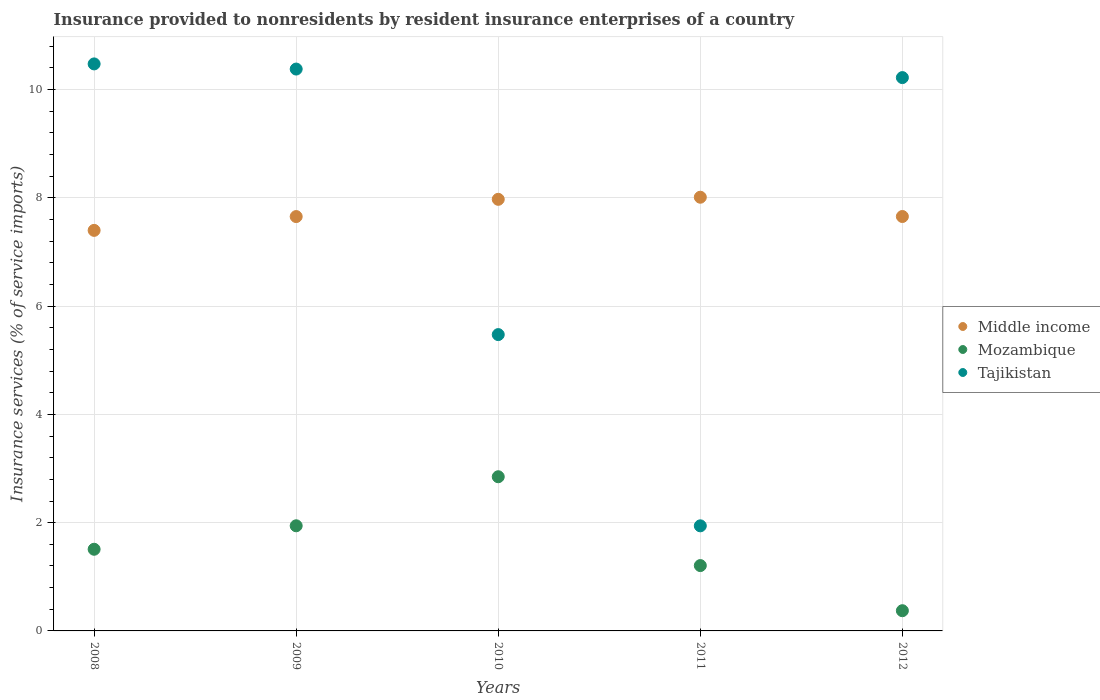How many different coloured dotlines are there?
Offer a terse response. 3. Is the number of dotlines equal to the number of legend labels?
Keep it short and to the point. Yes. What is the insurance provided to nonresidents in Tajikistan in 2012?
Your response must be concise. 10.22. Across all years, what is the maximum insurance provided to nonresidents in Tajikistan?
Offer a very short reply. 10.47. Across all years, what is the minimum insurance provided to nonresidents in Tajikistan?
Your response must be concise. 1.94. What is the total insurance provided to nonresidents in Middle income in the graph?
Make the answer very short. 38.69. What is the difference between the insurance provided to nonresidents in Middle income in 2008 and that in 2009?
Ensure brevity in your answer.  -0.26. What is the difference between the insurance provided to nonresidents in Middle income in 2008 and the insurance provided to nonresidents in Mozambique in 2012?
Keep it short and to the point. 7.03. What is the average insurance provided to nonresidents in Middle income per year?
Your response must be concise. 7.74. In the year 2009, what is the difference between the insurance provided to nonresidents in Tajikistan and insurance provided to nonresidents in Middle income?
Your answer should be very brief. 2.72. In how many years, is the insurance provided to nonresidents in Mozambique greater than 2.8 %?
Offer a very short reply. 1. What is the ratio of the insurance provided to nonresidents in Middle income in 2008 to that in 2012?
Offer a terse response. 0.97. What is the difference between the highest and the second highest insurance provided to nonresidents in Middle income?
Provide a short and direct response. 0.04. What is the difference between the highest and the lowest insurance provided to nonresidents in Middle income?
Offer a very short reply. 0.61. Is the sum of the insurance provided to nonresidents in Mozambique in 2008 and 2011 greater than the maximum insurance provided to nonresidents in Tajikistan across all years?
Provide a succinct answer. No. Is it the case that in every year, the sum of the insurance provided to nonresidents in Mozambique and insurance provided to nonresidents in Tajikistan  is greater than the insurance provided to nonresidents in Middle income?
Ensure brevity in your answer.  No. How many dotlines are there?
Your answer should be compact. 3. How many years are there in the graph?
Provide a succinct answer. 5. What is the difference between two consecutive major ticks on the Y-axis?
Offer a very short reply. 2. How are the legend labels stacked?
Make the answer very short. Vertical. What is the title of the graph?
Keep it short and to the point. Insurance provided to nonresidents by resident insurance enterprises of a country. Does "South Asia" appear as one of the legend labels in the graph?
Provide a succinct answer. No. What is the label or title of the Y-axis?
Offer a very short reply. Insurance services (% of service imports). What is the Insurance services (% of service imports) in Middle income in 2008?
Give a very brief answer. 7.4. What is the Insurance services (% of service imports) in Mozambique in 2008?
Provide a short and direct response. 1.51. What is the Insurance services (% of service imports) of Tajikistan in 2008?
Give a very brief answer. 10.47. What is the Insurance services (% of service imports) of Middle income in 2009?
Your answer should be compact. 7.65. What is the Insurance services (% of service imports) of Mozambique in 2009?
Your answer should be compact. 1.94. What is the Insurance services (% of service imports) of Tajikistan in 2009?
Your response must be concise. 10.38. What is the Insurance services (% of service imports) in Middle income in 2010?
Ensure brevity in your answer.  7.97. What is the Insurance services (% of service imports) in Mozambique in 2010?
Make the answer very short. 2.85. What is the Insurance services (% of service imports) in Tajikistan in 2010?
Offer a terse response. 5.47. What is the Insurance services (% of service imports) in Middle income in 2011?
Ensure brevity in your answer.  8.01. What is the Insurance services (% of service imports) in Mozambique in 2011?
Keep it short and to the point. 1.21. What is the Insurance services (% of service imports) of Tajikistan in 2011?
Ensure brevity in your answer.  1.94. What is the Insurance services (% of service imports) of Middle income in 2012?
Ensure brevity in your answer.  7.66. What is the Insurance services (% of service imports) of Mozambique in 2012?
Give a very brief answer. 0.37. What is the Insurance services (% of service imports) in Tajikistan in 2012?
Your answer should be compact. 10.22. Across all years, what is the maximum Insurance services (% of service imports) of Middle income?
Offer a terse response. 8.01. Across all years, what is the maximum Insurance services (% of service imports) of Mozambique?
Your answer should be very brief. 2.85. Across all years, what is the maximum Insurance services (% of service imports) in Tajikistan?
Provide a short and direct response. 10.47. Across all years, what is the minimum Insurance services (% of service imports) in Middle income?
Offer a very short reply. 7.4. Across all years, what is the minimum Insurance services (% of service imports) in Mozambique?
Your answer should be compact. 0.37. Across all years, what is the minimum Insurance services (% of service imports) in Tajikistan?
Your answer should be very brief. 1.94. What is the total Insurance services (% of service imports) of Middle income in the graph?
Provide a succinct answer. 38.69. What is the total Insurance services (% of service imports) of Mozambique in the graph?
Make the answer very short. 7.88. What is the total Insurance services (% of service imports) of Tajikistan in the graph?
Your answer should be very brief. 38.49. What is the difference between the Insurance services (% of service imports) in Middle income in 2008 and that in 2009?
Provide a succinct answer. -0.26. What is the difference between the Insurance services (% of service imports) of Mozambique in 2008 and that in 2009?
Provide a short and direct response. -0.43. What is the difference between the Insurance services (% of service imports) in Tajikistan in 2008 and that in 2009?
Make the answer very short. 0.1. What is the difference between the Insurance services (% of service imports) in Middle income in 2008 and that in 2010?
Make the answer very short. -0.57. What is the difference between the Insurance services (% of service imports) in Mozambique in 2008 and that in 2010?
Give a very brief answer. -1.34. What is the difference between the Insurance services (% of service imports) in Tajikistan in 2008 and that in 2010?
Provide a short and direct response. 5. What is the difference between the Insurance services (% of service imports) in Middle income in 2008 and that in 2011?
Ensure brevity in your answer.  -0.61. What is the difference between the Insurance services (% of service imports) of Mozambique in 2008 and that in 2011?
Make the answer very short. 0.3. What is the difference between the Insurance services (% of service imports) in Tajikistan in 2008 and that in 2011?
Keep it short and to the point. 8.53. What is the difference between the Insurance services (% of service imports) in Middle income in 2008 and that in 2012?
Your response must be concise. -0.26. What is the difference between the Insurance services (% of service imports) in Mozambique in 2008 and that in 2012?
Your response must be concise. 1.14. What is the difference between the Insurance services (% of service imports) of Tajikistan in 2008 and that in 2012?
Offer a very short reply. 0.25. What is the difference between the Insurance services (% of service imports) in Middle income in 2009 and that in 2010?
Ensure brevity in your answer.  -0.32. What is the difference between the Insurance services (% of service imports) in Mozambique in 2009 and that in 2010?
Offer a very short reply. -0.91. What is the difference between the Insurance services (% of service imports) in Tajikistan in 2009 and that in 2010?
Ensure brevity in your answer.  4.91. What is the difference between the Insurance services (% of service imports) in Middle income in 2009 and that in 2011?
Make the answer very short. -0.36. What is the difference between the Insurance services (% of service imports) of Mozambique in 2009 and that in 2011?
Provide a succinct answer. 0.74. What is the difference between the Insurance services (% of service imports) in Tajikistan in 2009 and that in 2011?
Your answer should be very brief. 8.44. What is the difference between the Insurance services (% of service imports) in Middle income in 2009 and that in 2012?
Give a very brief answer. -0. What is the difference between the Insurance services (% of service imports) of Mozambique in 2009 and that in 2012?
Offer a very short reply. 1.57. What is the difference between the Insurance services (% of service imports) in Tajikistan in 2009 and that in 2012?
Ensure brevity in your answer.  0.16. What is the difference between the Insurance services (% of service imports) in Middle income in 2010 and that in 2011?
Your answer should be compact. -0.04. What is the difference between the Insurance services (% of service imports) of Mozambique in 2010 and that in 2011?
Your answer should be very brief. 1.64. What is the difference between the Insurance services (% of service imports) in Tajikistan in 2010 and that in 2011?
Provide a short and direct response. 3.53. What is the difference between the Insurance services (% of service imports) of Middle income in 2010 and that in 2012?
Your answer should be compact. 0.32. What is the difference between the Insurance services (% of service imports) of Mozambique in 2010 and that in 2012?
Provide a short and direct response. 2.47. What is the difference between the Insurance services (% of service imports) of Tajikistan in 2010 and that in 2012?
Offer a terse response. -4.75. What is the difference between the Insurance services (% of service imports) in Middle income in 2011 and that in 2012?
Ensure brevity in your answer.  0.36. What is the difference between the Insurance services (% of service imports) in Mozambique in 2011 and that in 2012?
Provide a short and direct response. 0.83. What is the difference between the Insurance services (% of service imports) of Tajikistan in 2011 and that in 2012?
Ensure brevity in your answer.  -8.28. What is the difference between the Insurance services (% of service imports) of Middle income in 2008 and the Insurance services (% of service imports) of Mozambique in 2009?
Keep it short and to the point. 5.46. What is the difference between the Insurance services (% of service imports) in Middle income in 2008 and the Insurance services (% of service imports) in Tajikistan in 2009?
Make the answer very short. -2.98. What is the difference between the Insurance services (% of service imports) in Mozambique in 2008 and the Insurance services (% of service imports) in Tajikistan in 2009?
Make the answer very short. -8.87. What is the difference between the Insurance services (% of service imports) of Middle income in 2008 and the Insurance services (% of service imports) of Mozambique in 2010?
Provide a short and direct response. 4.55. What is the difference between the Insurance services (% of service imports) in Middle income in 2008 and the Insurance services (% of service imports) in Tajikistan in 2010?
Keep it short and to the point. 1.93. What is the difference between the Insurance services (% of service imports) in Mozambique in 2008 and the Insurance services (% of service imports) in Tajikistan in 2010?
Your answer should be compact. -3.97. What is the difference between the Insurance services (% of service imports) in Middle income in 2008 and the Insurance services (% of service imports) in Mozambique in 2011?
Your response must be concise. 6.19. What is the difference between the Insurance services (% of service imports) in Middle income in 2008 and the Insurance services (% of service imports) in Tajikistan in 2011?
Your answer should be very brief. 5.46. What is the difference between the Insurance services (% of service imports) of Mozambique in 2008 and the Insurance services (% of service imports) of Tajikistan in 2011?
Your answer should be very brief. -0.43. What is the difference between the Insurance services (% of service imports) of Middle income in 2008 and the Insurance services (% of service imports) of Mozambique in 2012?
Offer a very short reply. 7.03. What is the difference between the Insurance services (% of service imports) of Middle income in 2008 and the Insurance services (% of service imports) of Tajikistan in 2012?
Give a very brief answer. -2.82. What is the difference between the Insurance services (% of service imports) in Mozambique in 2008 and the Insurance services (% of service imports) in Tajikistan in 2012?
Offer a terse response. -8.71. What is the difference between the Insurance services (% of service imports) of Middle income in 2009 and the Insurance services (% of service imports) of Mozambique in 2010?
Provide a succinct answer. 4.81. What is the difference between the Insurance services (% of service imports) in Middle income in 2009 and the Insurance services (% of service imports) in Tajikistan in 2010?
Your answer should be very brief. 2.18. What is the difference between the Insurance services (% of service imports) in Mozambique in 2009 and the Insurance services (% of service imports) in Tajikistan in 2010?
Your answer should be very brief. -3.53. What is the difference between the Insurance services (% of service imports) in Middle income in 2009 and the Insurance services (% of service imports) in Mozambique in 2011?
Provide a short and direct response. 6.45. What is the difference between the Insurance services (% of service imports) in Middle income in 2009 and the Insurance services (% of service imports) in Tajikistan in 2011?
Offer a very short reply. 5.71. What is the difference between the Insurance services (% of service imports) of Mozambique in 2009 and the Insurance services (% of service imports) of Tajikistan in 2011?
Provide a short and direct response. 0. What is the difference between the Insurance services (% of service imports) in Middle income in 2009 and the Insurance services (% of service imports) in Mozambique in 2012?
Your answer should be compact. 7.28. What is the difference between the Insurance services (% of service imports) of Middle income in 2009 and the Insurance services (% of service imports) of Tajikistan in 2012?
Offer a terse response. -2.57. What is the difference between the Insurance services (% of service imports) in Mozambique in 2009 and the Insurance services (% of service imports) in Tajikistan in 2012?
Make the answer very short. -8.28. What is the difference between the Insurance services (% of service imports) in Middle income in 2010 and the Insurance services (% of service imports) in Mozambique in 2011?
Keep it short and to the point. 6.77. What is the difference between the Insurance services (% of service imports) in Middle income in 2010 and the Insurance services (% of service imports) in Tajikistan in 2011?
Give a very brief answer. 6.03. What is the difference between the Insurance services (% of service imports) in Mozambique in 2010 and the Insurance services (% of service imports) in Tajikistan in 2011?
Your response must be concise. 0.91. What is the difference between the Insurance services (% of service imports) of Middle income in 2010 and the Insurance services (% of service imports) of Mozambique in 2012?
Make the answer very short. 7.6. What is the difference between the Insurance services (% of service imports) of Middle income in 2010 and the Insurance services (% of service imports) of Tajikistan in 2012?
Keep it short and to the point. -2.25. What is the difference between the Insurance services (% of service imports) in Mozambique in 2010 and the Insurance services (% of service imports) in Tajikistan in 2012?
Offer a terse response. -7.37. What is the difference between the Insurance services (% of service imports) of Middle income in 2011 and the Insurance services (% of service imports) of Mozambique in 2012?
Offer a very short reply. 7.64. What is the difference between the Insurance services (% of service imports) in Middle income in 2011 and the Insurance services (% of service imports) in Tajikistan in 2012?
Offer a terse response. -2.21. What is the difference between the Insurance services (% of service imports) in Mozambique in 2011 and the Insurance services (% of service imports) in Tajikistan in 2012?
Your answer should be very brief. -9.01. What is the average Insurance services (% of service imports) in Middle income per year?
Give a very brief answer. 7.74. What is the average Insurance services (% of service imports) in Mozambique per year?
Your answer should be very brief. 1.58. What is the average Insurance services (% of service imports) of Tajikistan per year?
Keep it short and to the point. 7.7. In the year 2008, what is the difference between the Insurance services (% of service imports) of Middle income and Insurance services (% of service imports) of Mozambique?
Make the answer very short. 5.89. In the year 2008, what is the difference between the Insurance services (% of service imports) of Middle income and Insurance services (% of service imports) of Tajikistan?
Make the answer very short. -3.08. In the year 2008, what is the difference between the Insurance services (% of service imports) of Mozambique and Insurance services (% of service imports) of Tajikistan?
Your response must be concise. -8.97. In the year 2009, what is the difference between the Insurance services (% of service imports) in Middle income and Insurance services (% of service imports) in Mozambique?
Offer a very short reply. 5.71. In the year 2009, what is the difference between the Insurance services (% of service imports) of Middle income and Insurance services (% of service imports) of Tajikistan?
Give a very brief answer. -2.72. In the year 2009, what is the difference between the Insurance services (% of service imports) in Mozambique and Insurance services (% of service imports) in Tajikistan?
Your answer should be compact. -8.44. In the year 2010, what is the difference between the Insurance services (% of service imports) of Middle income and Insurance services (% of service imports) of Mozambique?
Ensure brevity in your answer.  5.12. In the year 2010, what is the difference between the Insurance services (% of service imports) of Middle income and Insurance services (% of service imports) of Tajikistan?
Make the answer very short. 2.5. In the year 2010, what is the difference between the Insurance services (% of service imports) of Mozambique and Insurance services (% of service imports) of Tajikistan?
Provide a short and direct response. -2.63. In the year 2011, what is the difference between the Insurance services (% of service imports) in Middle income and Insurance services (% of service imports) in Mozambique?
Ensure brevity in your answer.  6.8. In the year 2011, what is the difference between the Insurance services (% of service imports) in Middle income and Insurance services (% of service imports) in Tajikistan?
Ensure brevity in your answer.  6.07. In the year 2011, what is the difference between the Insurance services (% of service imports) in Mozambique and Insurance services (% of service imports) in Tajikistan?
Give a very brief answer. -0.73. In the year 2012, what is the difference between the Insurance services (% of service imports) in Middle income and Insurance services (% of service imports) in Mozambique?
Ensure brevity in your answer.  7.28. In the year 2012, what is the difference between the Insurance services (% of service imports) in Middle income and Insurance services (% of service imports) in Tajikistan?
Make the answer very short. -2.57. In the year 2012, what is the difference between the Insurance services (% of service imports) in Mozambique and Insurance services (% of service imports) in Tajikistan?
Offer a terse response. -9.85. What is the ratio of the Insurance services (% of service imports) of Middle income in 2008 to that in 2009?
Give a very brief answer. 0.97. What is the ratio of the Insurance services (% of service imports) in Mozambique in 2008 to that in 2009?
Your response must be concise. 0.78. What is the ratio of the Insurance services (% of service imports) in Tajikistan in 2008 to that in 2009?
Offer a terse response. 1.01. What is the ratio of the Insurance services (% of service imports) of Middle income in 2008 to that in 2010?
Your answer should be compact. 0.93. What is the ratio of the Insurance services (% of service imports) in Mozambique in 2008 to that in 2010?
Provide a succinct answer. 0.53. What is the ratio of the Insurance services (% of service imports) in Tajikistan in 2008 to that in 2010?
Your answer should be very brief. 1.91. What is the ratio of the Insurance services (% of service imports) in Middle income in 2008 to that in 2011?
Ensure brevity in your answer.  0.92. What is the ratio of the Insurance services (% of service imports) in Mozambique in 2008 to that in 2011?
Keep it short and to the point. 1.25. What is the ratio of the Insurance services (% of service imports) of Tajikistan in 2008 to that in 2011?
Make the answer very short. 5.4. What is the ratio of the Insurance services (% of service imports) in Middle income in 2008 to that in 2012?
Your response must be concise. 0.97. What is the ratio of the Insurance services (% of service imports) in Mozambique in 2008 to that in 2012?
Offer a very short reply. 4.04. What is the ratio of the Insurance services (% of service imports) of Tajikistan in 2008 to that in 2012?
Keep it short and to the point. 1.02. What is the ratio of the Insurance services (% of service imports) in Middle income in 2009 to that in 2010?
Keep it short and to the point. 0.96. What is the ratio of the Insurance services (% of service imports) in Mozambique in 2009 to that in 2010?
Offer a very short reply. 0.68. What is the ratio of the Insurance services (% of service imports) of Tajikistan in 2009 to that in 2010?
Give a very brief answer. 1.9. What is the ratio of the Insurance services (% of service imports) of Middle income in 2009 to that in 2011?
Your response must be concise. 0.96. What is the ratio of the Insurance services (% of service imports) in Mozambique in 2009 to that in 2011?
Keep it short and to the point. 1.61. What is the ratio of the Insurance services (% of service imports) in Tajikistan in 2009 to that in 2011?
Offer a terse response. 5.35. What is the ratio of the Insurance services (% of service imports) of Mozambique in 2009 to that in 2012?
Keep it short and to the point. 5.2. What is the ratio of the Insurance services (% of service imports) in Tajikistan in 2009 to that in 2012?
Provide a short and direct response. 1.02. What is the ratio of the Insurance services (% of service imports) in Middle income in 2010 to that in 2011?
Ensure brevity in your answer.  1. What is the ratio of the Insurance services (% of service imports) of Mozambique in 2010 to that in 2011?
Your answer should be very brief. 2.36. What is the ratio of the Insurance services (% of service imports) of Tajikistan in 2010 to that in 2011?
Offer a very short reply. 2.82. What is the ratio of the Insurance services (% of service imports) of Middle income in 2010 to that in 2012?
Your response must be concise. 1.04. What is the ratio of the Insurance services (% of service imports) in Mozambique in 2010 to that in 2012?
Offer a terse response. 7.63. What is the ratio of the Insurance services (% of service imports) in Tajikistan in 2010 to that in 2012?
Your answer should be very brief. 0.54. What is the ratio of the Insurance services (% of service imports) in Middle income in 2011 to that in 2012?
Provide a succinct answer. 1.05. What is the ratio of the Insurance services (% of service imports) of Mozambique in 2011 to that in 2012?
Keep it short and to the point. 3.23. What is the ratio of the Insurance services (% of service imports) of Tajikistan in 2011 to that in 2012?
Your answer should be compact. 0.19. What is the difference between the highest and the second highest Insurance services (% of service imports) in Middle income?
Ensure brevity in your answer.  0.04. What is the difference between the highest and the second highest Insurance services (% of service imports) of Mozambique?
Keep it short and to the point. 0.91. What is the difference between the highest and the second highest Insurance services (% of service imports) of Tajikistan?
Provide a succinct answer. 0.1. What is the difference between the highest and the lowest Insurance services (% of service imports) in Middle income?
Give a very brief answer. 0.61. What is the difference between the highest and the lowest Insurance services (% of service imports) of Mozambique?
Make the answer very short. 2.47. What is the difference between the highest and the lowest Insurance services (% of service imports) of Tajikistan?
Your answer should be very brief. 8.53. 